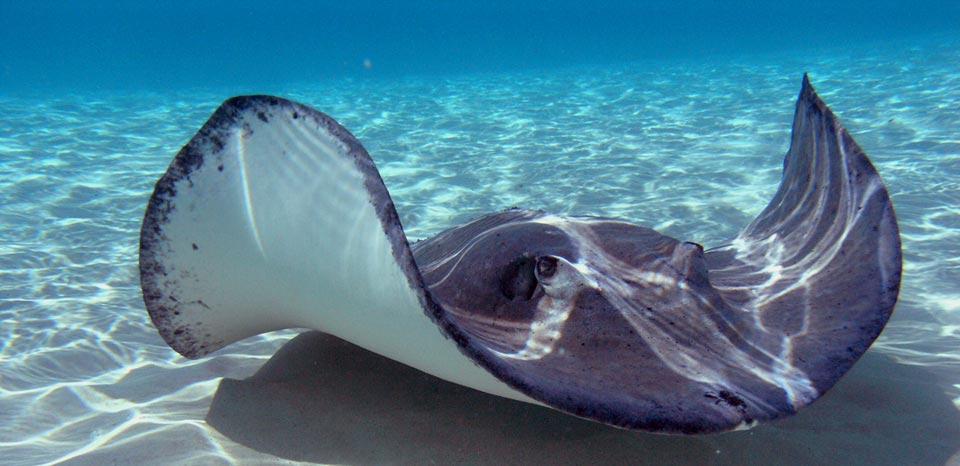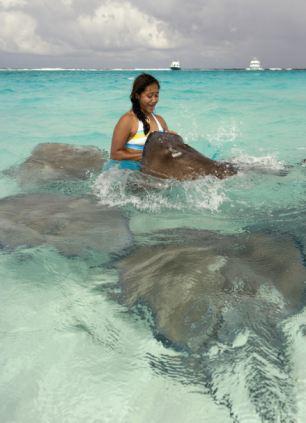The first image is the image on the left, the second image is the image on the right. Evaluate the accuracy of this statement regarding the images: "A person whose head and chest are above water is behind a stingray in the ocean.". Is it true? Answer yes or no. Yes. The first image is the image on the left, the second image is the image on the right. Evaluate the accuracy of this statement regarding the images: "An image contains a human touching a sting ray.". Is it true? Answer yes or no. Yes. 